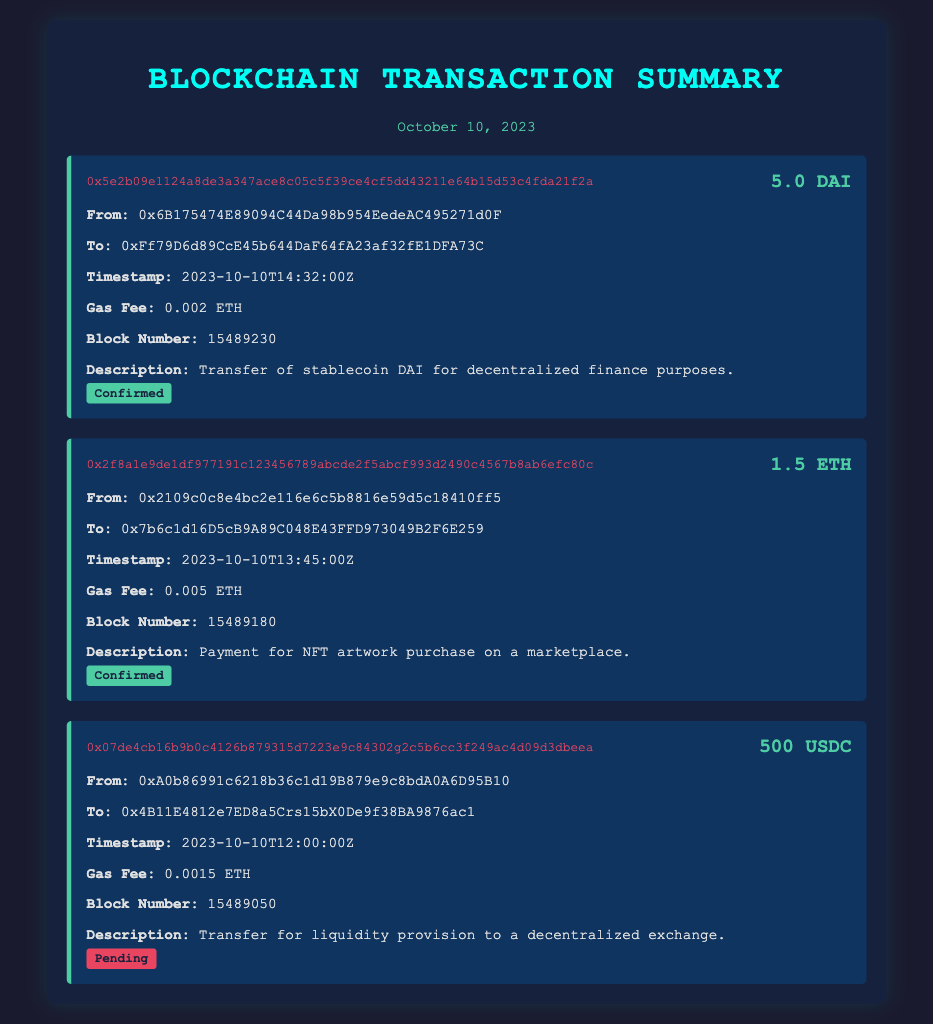What is the timestamp of the first transaction? The timestamp indicates when the transaction occurred, which is listed as 2023-10-10T14:32:00Z.
Answer: 2023-10-10T14:32:00Z What is the gas fee for the second transaction? The gas fee for each transaction is specified, and for the second transaction, it is 0.005 ETH.
Answer: 0.005 ETH What amount of USDC was transferred in the third transaction? The amount transferred is specified in the transaction details, which states 500 USDC was sent.
Answer: 500 USDC How many transactions are confirmed? The document indicates the status of each transaction, with "Confirmed" shown for two of them.
Answer: 2 What is the description of the first transaction? The description provides context for the transaction's purpose, which states it was a transfer of stablecoin DAI for decentralized finance purposes.
Answer: Transfer of stablecoin DAI for decentralized finance purposes 